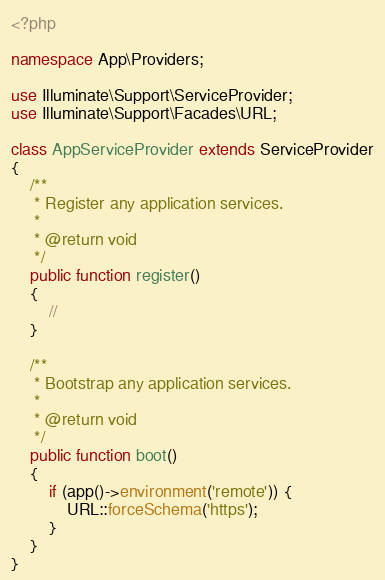<code> <loc_0><loc_0><loc_500><loc_500><_PHP_><?php

namespace App\Providers;

use Illuminate\Support\ServiceProvider;
use Illuminate\Support\Facades\URL;

class AppServiceProvider extends ServiceProvider
{
    /**
     * Register any application services.
     *
     * @return void
     */
    public function register()
    {
        //
    }

    /**
     * Bootstrap any application services.
     *
     * @return void
     */
    public function boot()
    {
        if (app()->environment('remote')) {
            URL::forceSchema('https');
        }
    }
}
</code> 